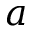Convert formula to latex. <formula><loc_0><loc_0><loc_500><loc_500>a</formula> 